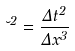Convert formula to latex. <formula><loc_0><loc_0><loc_500><loc_500>\lambda ^ { 2 } = \frac { \Delta t ^ { 2 } } { \Delta x ^ { 3 } }</formula> 